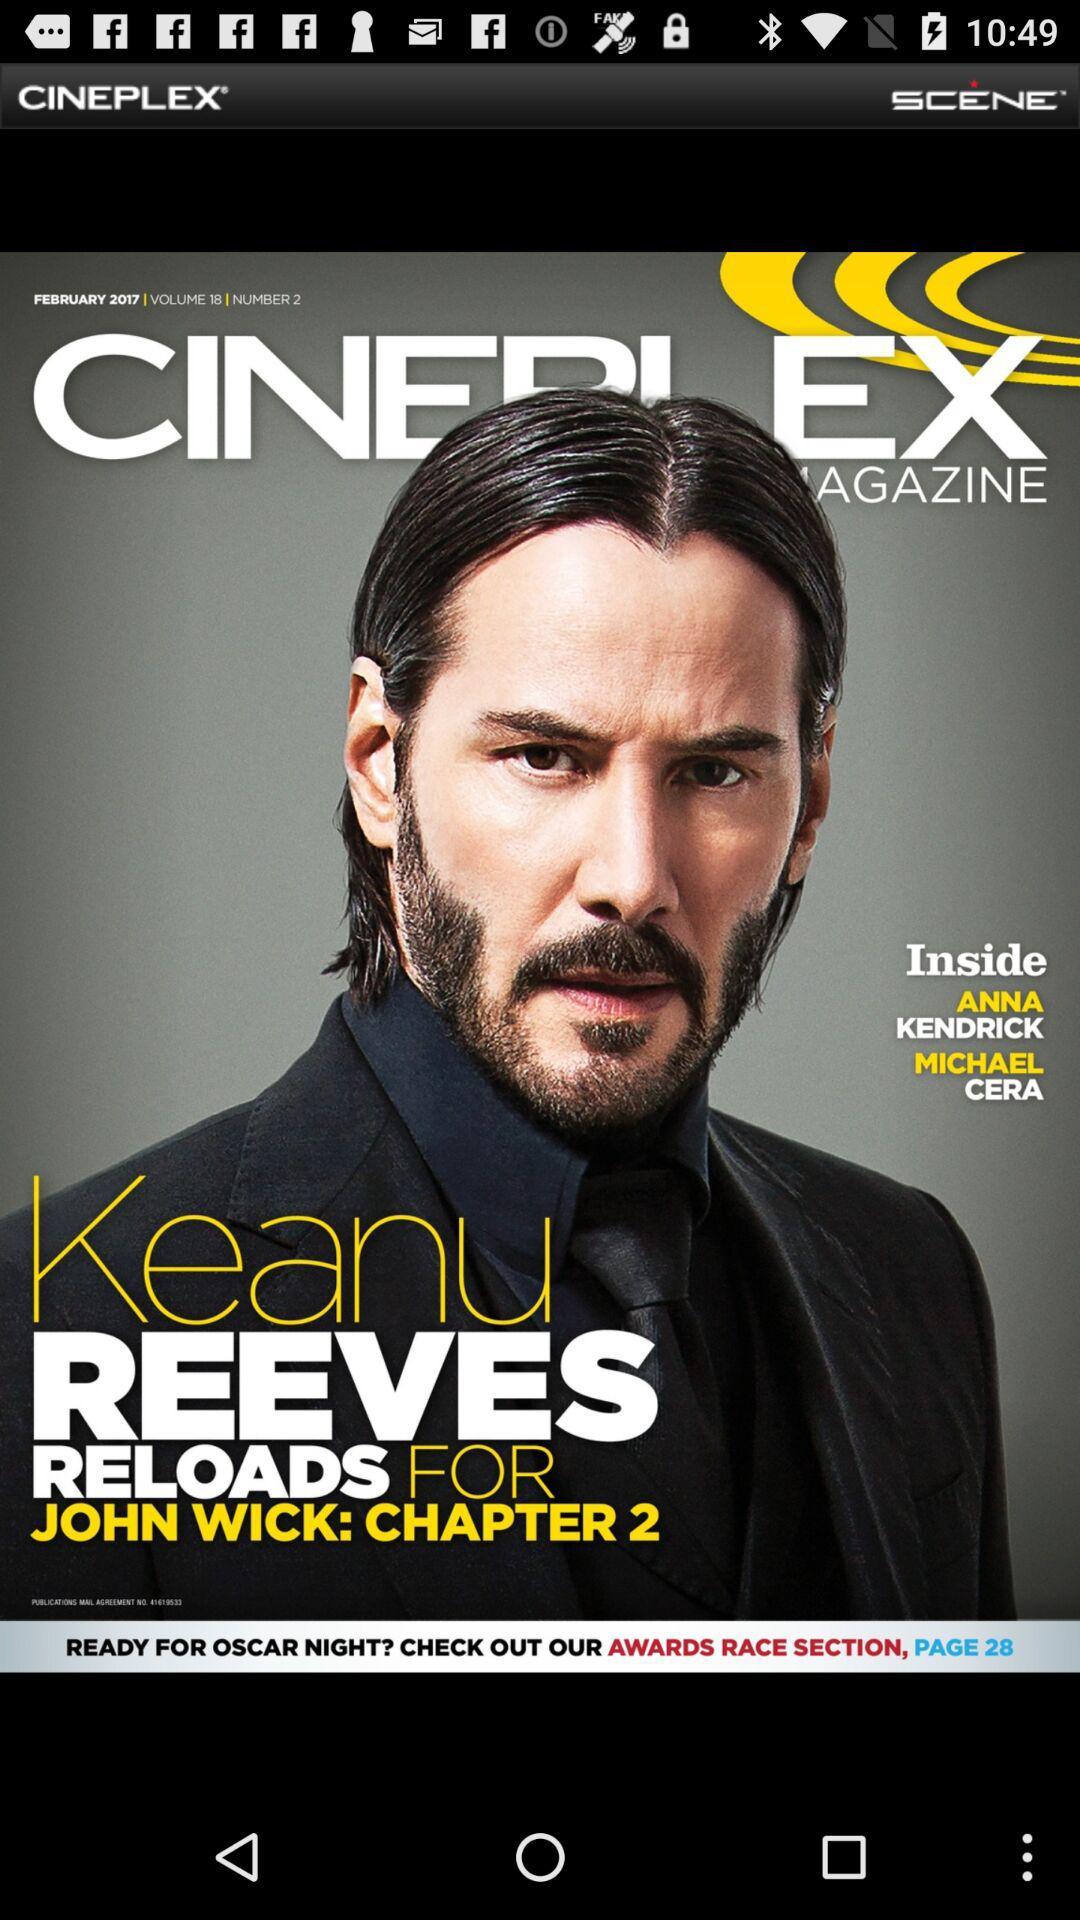On what page number can the awards race section be checked out? The awards race section can be checked out on page number 28. 